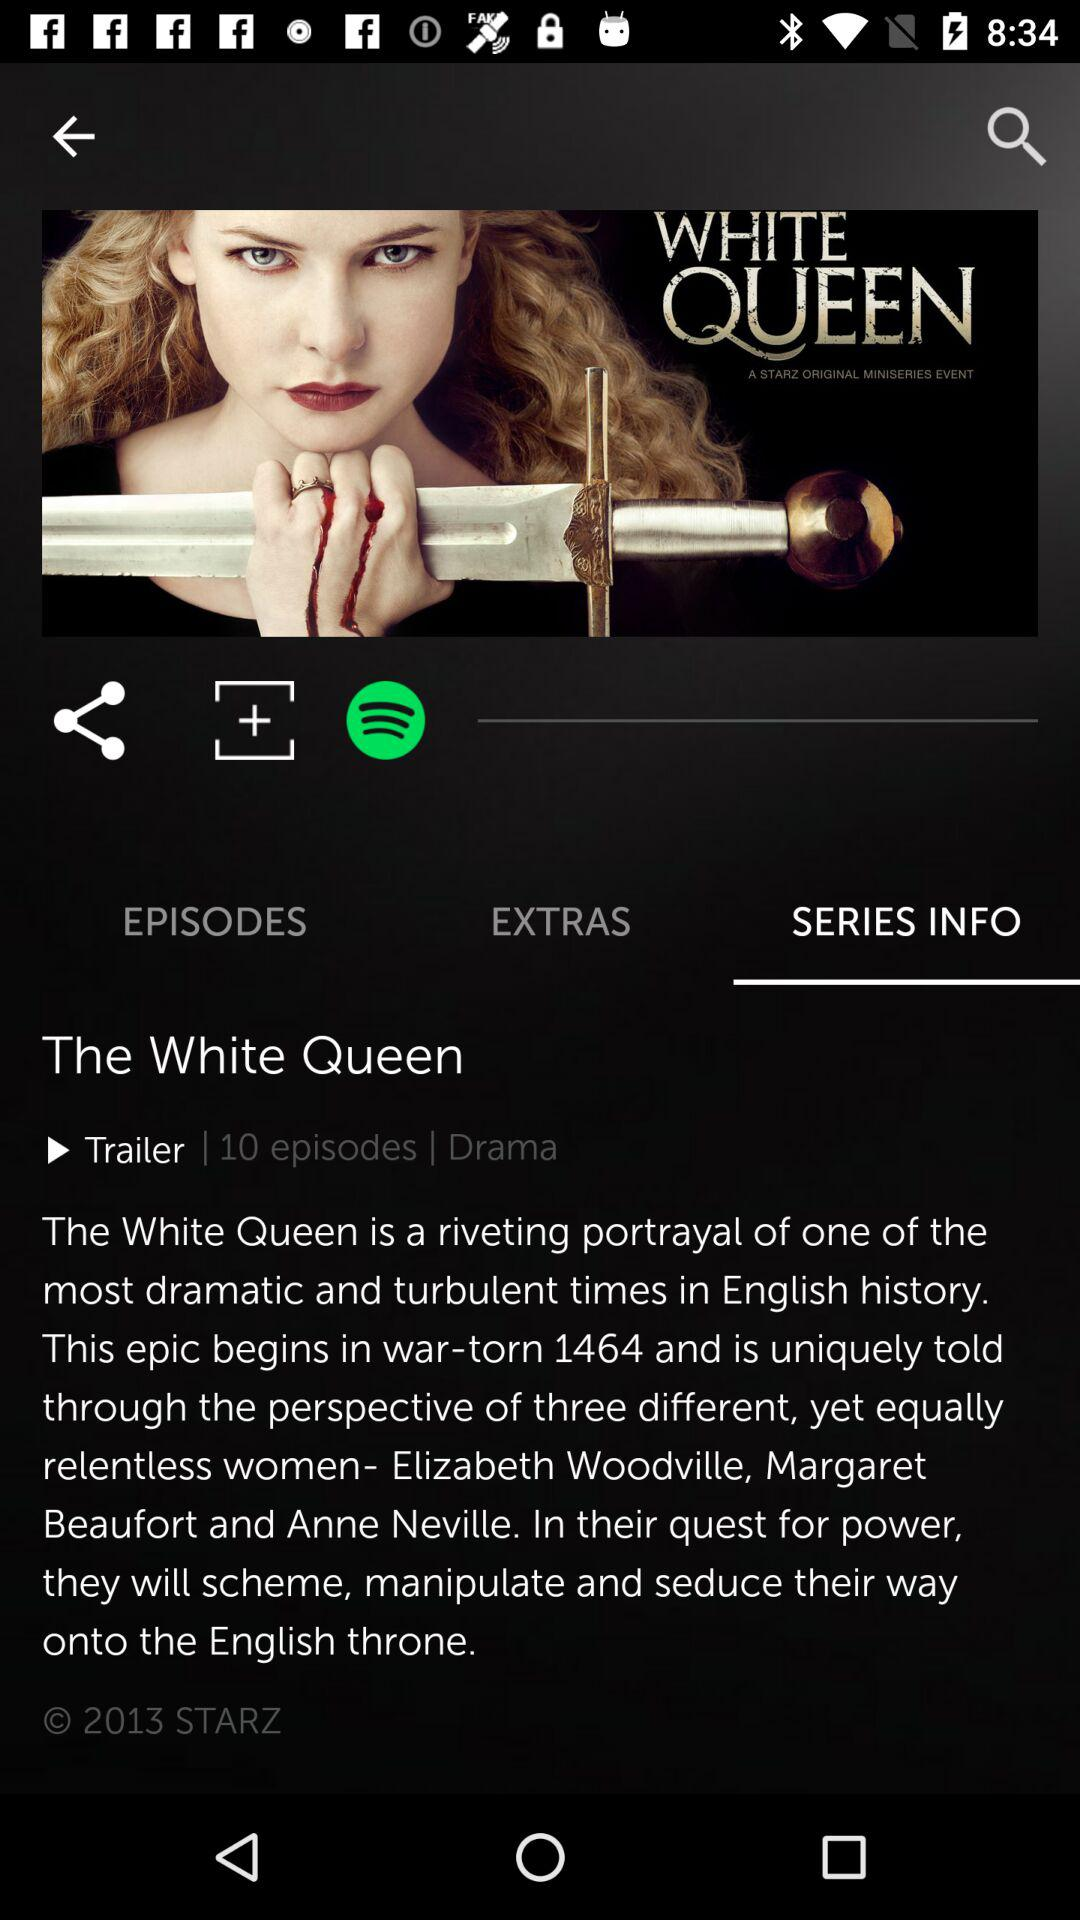When did the epic begin? The epic began in 1464. 